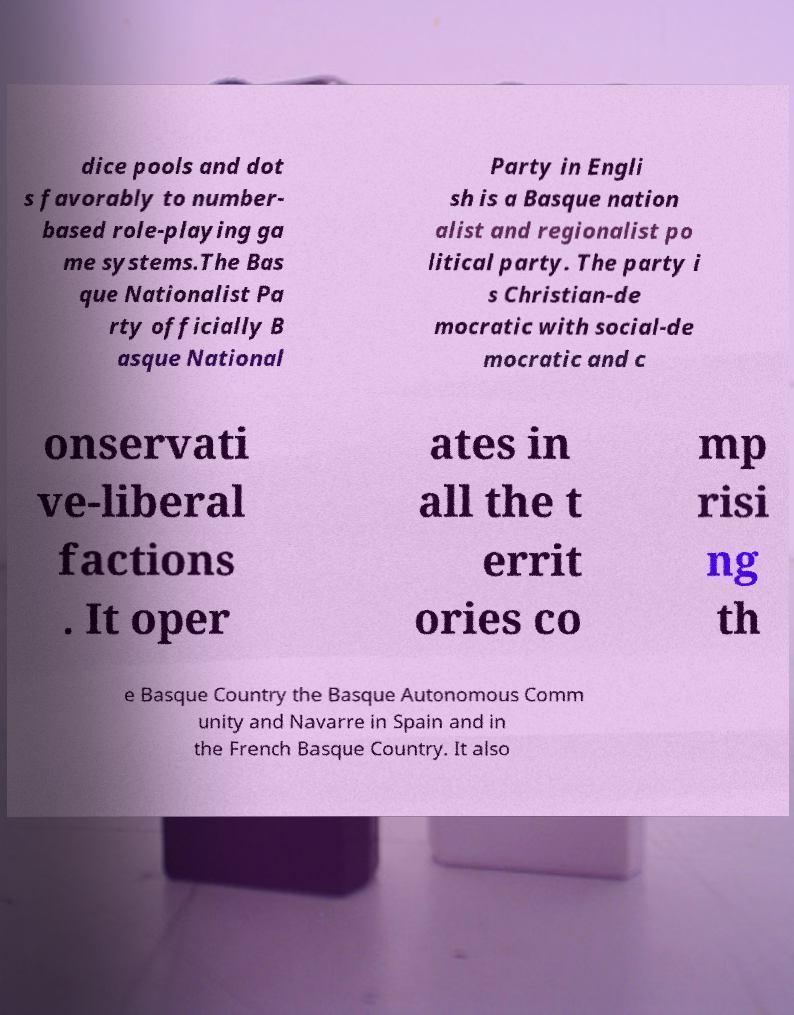Please read and relay the text visible in this image. What does it say? dice pools and dot s favorably to number- based role-playing ga me systems.The Bas que Nationalist Pa rty officially B asque National Party in Engli sh is a Basque nation alist and regionalist po litical party. The party i s Christian-de mocratic with social-de mocratic and c onservati ve-liberal factions . It oper ates in all the t errit ories co mp risi ng th e Basque Country the Basque Autonomous Comm unity and Navarre in Spain and in the French Basque Country. It also 